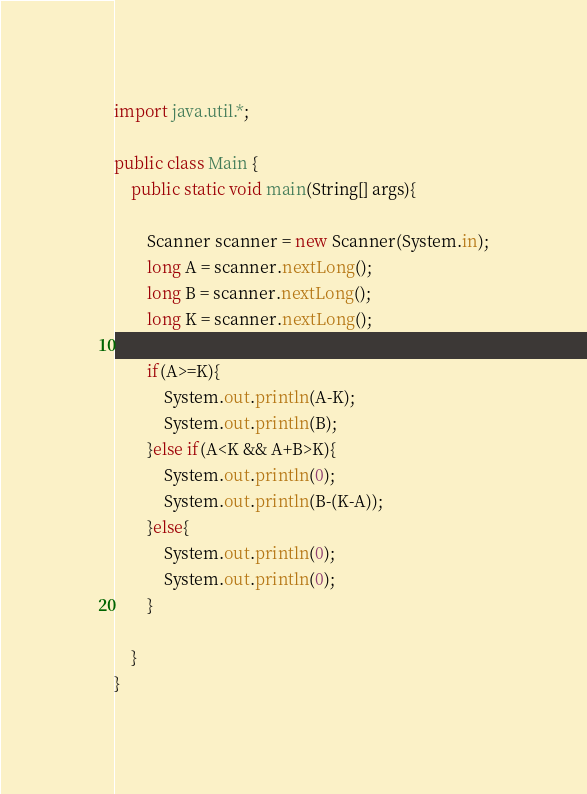Convert code to text. <code><loc_0><loc_0><loc_500><loc_500><_Java_>import java.util.*;

public class Main {
    public static void main(String[] args){
        
        Scanner scanner = new Scanner(System.in);
        long A = scanner.nextLong();
        long B = scanner.nextLong();
        long K = scanner.nextLong();
        
        if(A>=K){
            System.out.println(A-K);
            System.out.println(B);
        }else if(A<K && A+B>K){
            System.out.println(0);
            System.out.println(B-(K-A));
        }else{
            System.out.println(0);
            System.out.println(0);
        }
        
    }
}
</code> 